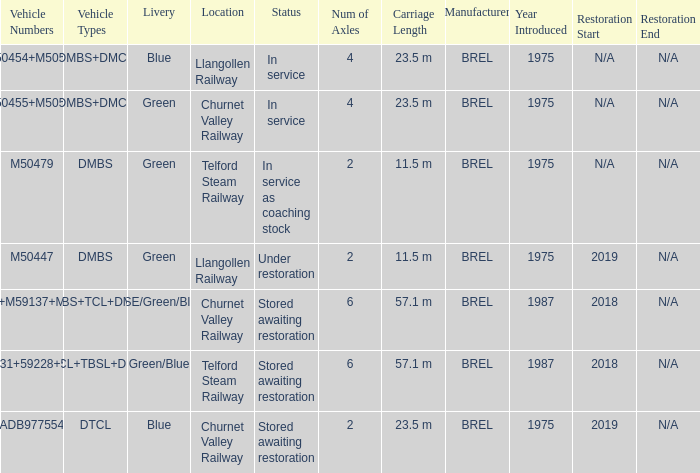What status is the vehicle numbers of adb977554? Stored awaiting restoration. 